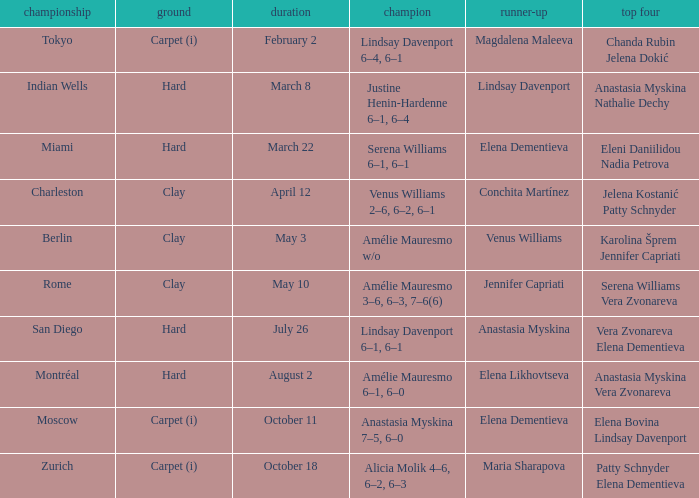Who were the semifinalists in the Rome tournament? Serena Williams Vera Zvonareva. 